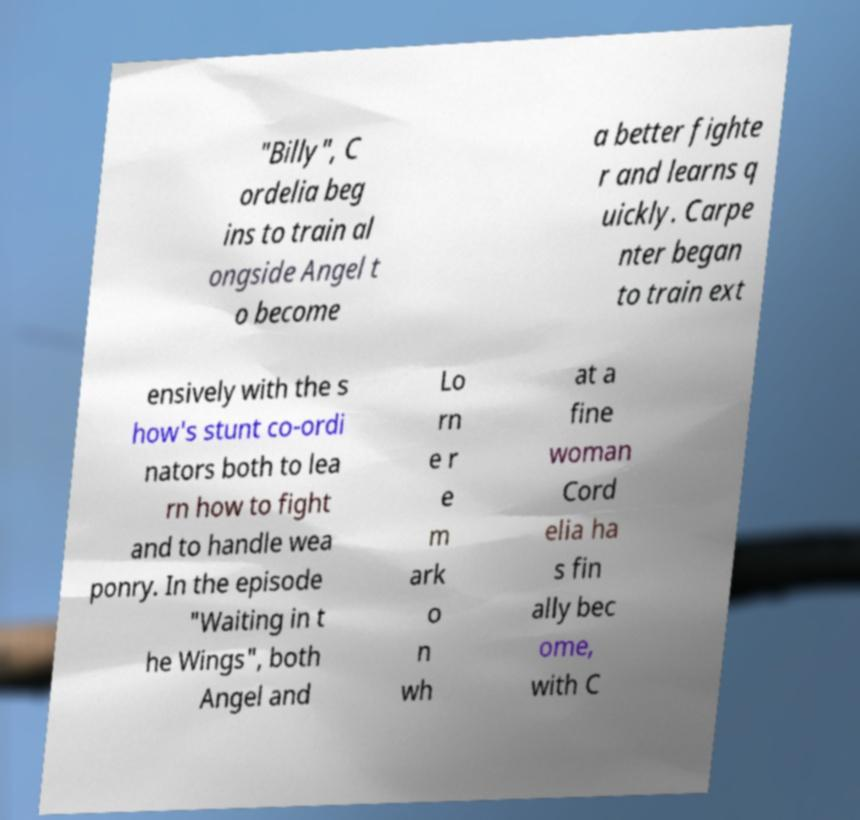I need the written content from this picture converted into text. Can you do that? "Billy", C ordelia beg ins to train al ongside Angel t o become a better fighte r and learns q uickly. Carpe nter began to train ext ensively with the s how's stunt co-ordi nators both to lea rn how to fight and to handle wea ponry. In the episode "Waiting in t he Wings", both Angel and Lo rn e r e m ark o n wh at a fine woman Cord elia ha s fin ally bec ome, with C 